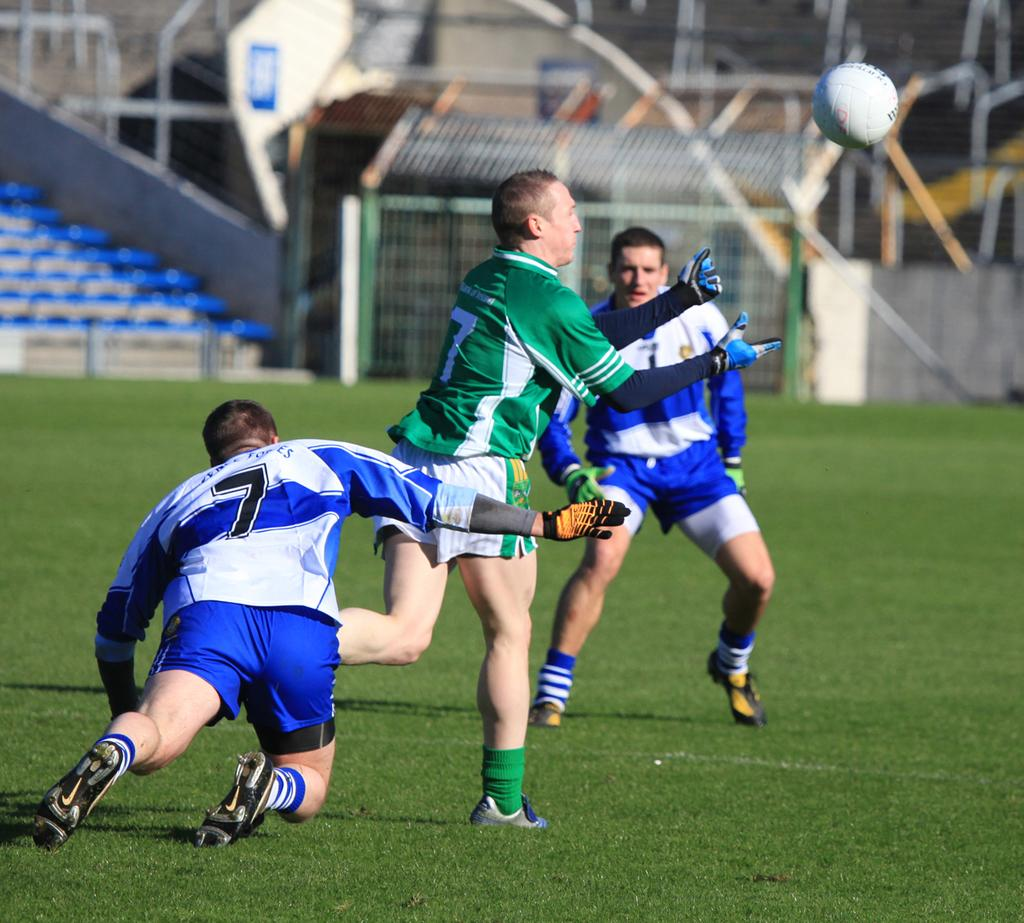<image>
Offer a succinct explanation of the picture presented. Three soccer players are playing and two of them are wearing number 7 